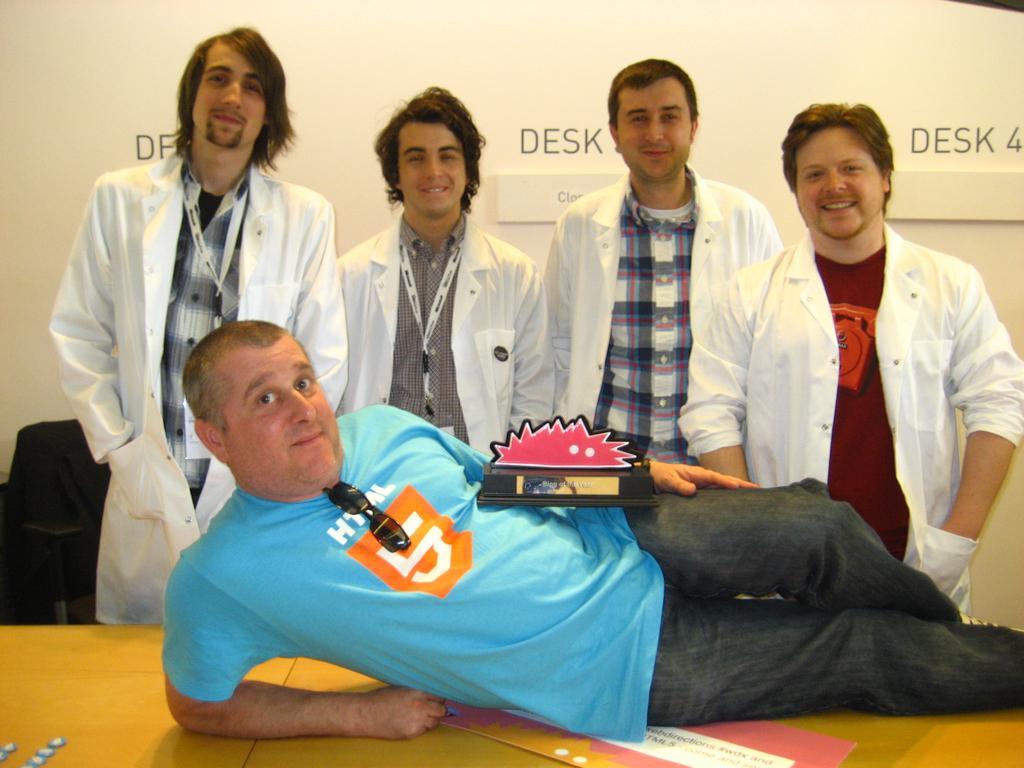Could you give a brief overview of what you see in this image? In the picture I can see 4 people are standing and one man is lying on a wooden surface. The people in the back is wearing white color coats and smiling. On the wooden surface I can see some objects. 